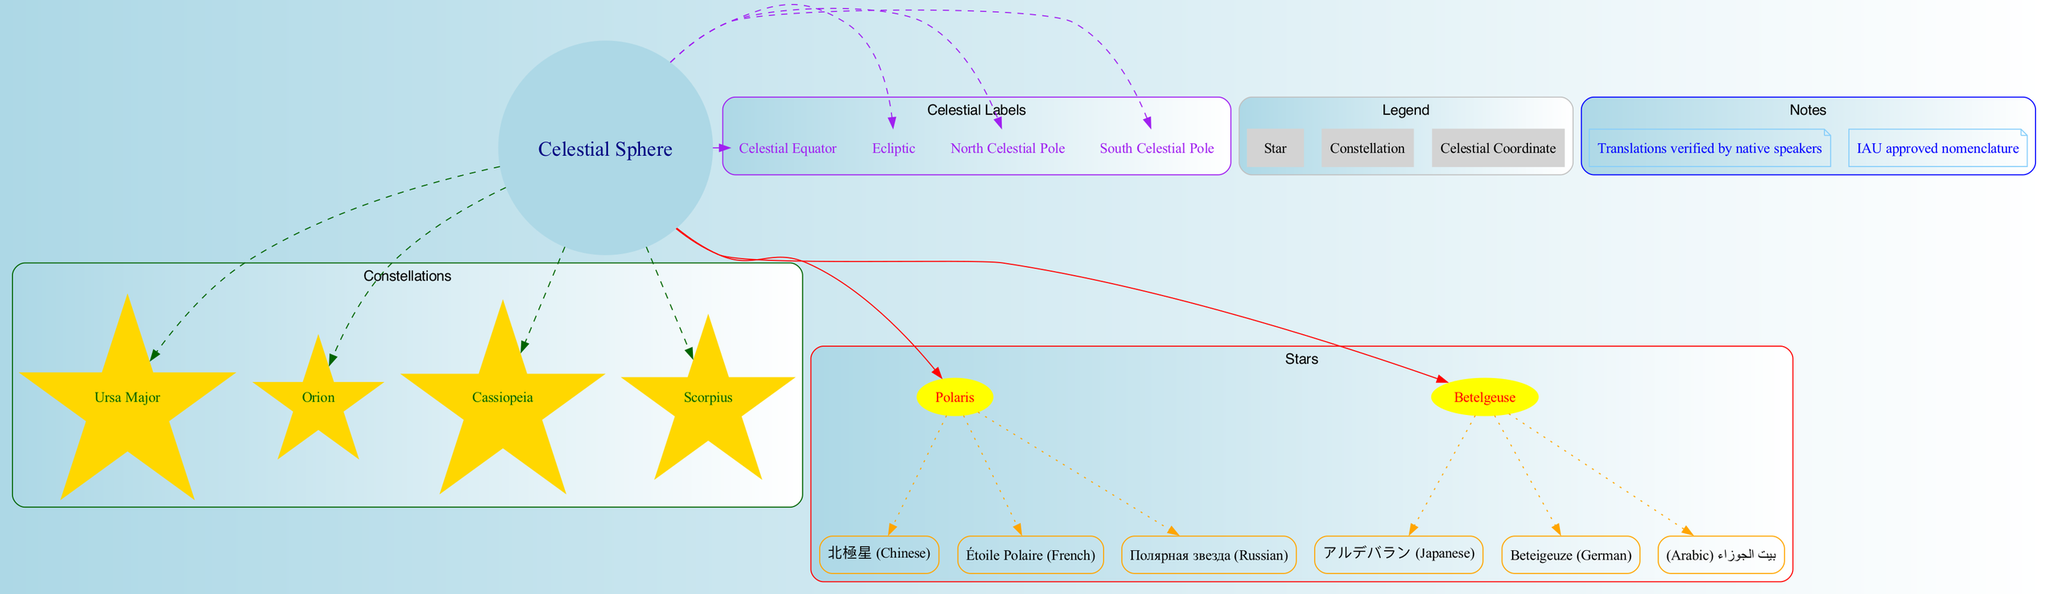What is the center of the celestial sphere diagram? The diagram identifies the central node as "Celestial Sphere," which is indicated in a circular node labeled at the center of the diagram.
Answer: Celestial Sphere How many constellations are displayed in the diagram? The diagram contains four distinct constellation nodes, each connected to the center node, labeled as Ursa Major, Orion, Cassiopeia, and Scorpius.
Answer: 4 What is the name of the star represented by the box labeled 'アルデバラン'? The box labeled 'アルデバラン' corresponds to the star Betelgeuse, which is indicated by the solid connection shown from the center node.
Answer: Betelgeuse Which star has translations in Chinese, French, and Russian? The translations in Chinese '北極星', French 'Étoile Polaire', and Russian 'Полярная звезда' correspond to the star Polaris, as indicated by its associated translation nodes directly connected to it.
Answer: Polaris How many labels are connected to the center node? The diagram has four label nodes namely 'Celestial Equator', 'Ecliptic', 'North Celestial Pole', and 'South Celestial Pole', each dashed towards the center node, thus totaling four.
Answer: 4 What color represents the constellations in the diagram? The constellations are represented in gold color, which is used for all the star-shaped nodes specific to this category.
Answer: Gold Which constellation is connected to the center by a dashed edge with a dark green color? The constellation Orion is one of the nodes connected to the center with a dashed dark green edge, indicating its relationship as a constellation within the diagram.
Answer: Orion What type of note is used to present additional information at the bottom of the diagram? The diagram uses a note shape colored in lightskyblue to display supplementary notes about the translations and the approved nomenclature from IAU.
Answer: Note How many predetermined translations are provided for the star Betelgeuse? The star Betelgeuse has three different translations provided in the corresponding nodes: Japanese, German, and Arabic, connecting back to the star node.
Answer: 3 